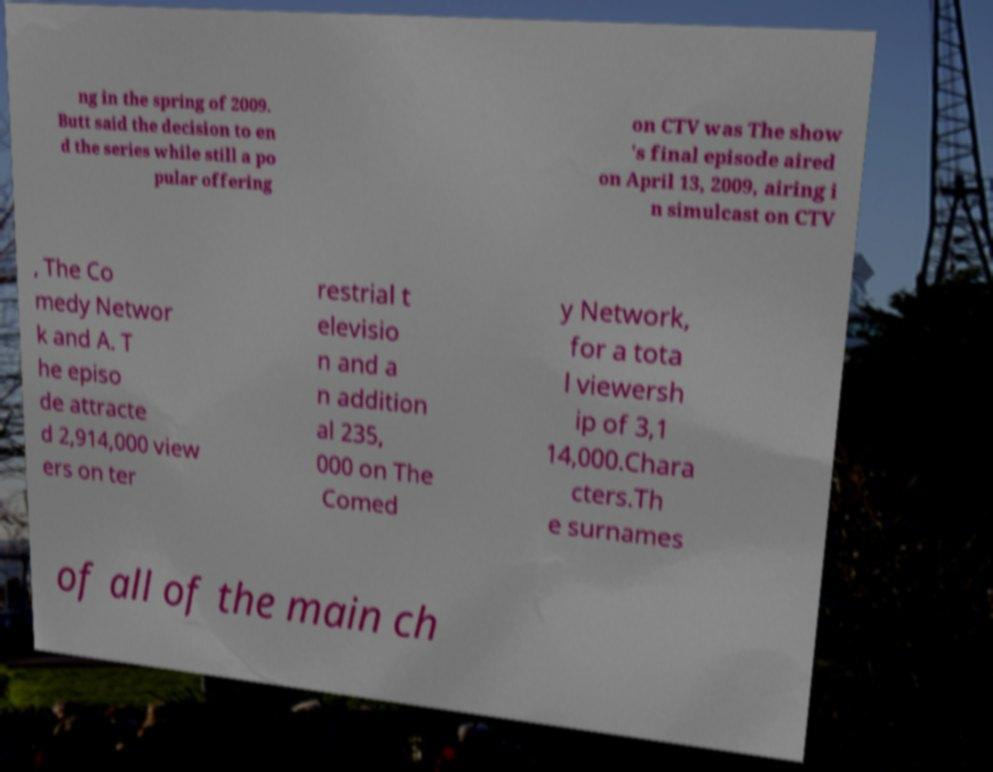Could you assist in decoding the text presented in this image and type it out clearly? ng in the spring of 2009. Butt said the decision to en d the series while still a po pular offering on CTV was The show 's final episode aired on April 13, 2009, airing i n simulcast on CTV , The Co medy Networ k and A. T he episo de attracte d 2,914,000 view ers on ter restrial t elevisio n and a n addition al 235, 000 on The Comed y Network, for a tota l viewersh ip of 3,1 14,000.Chara cters.Th e surnames of all of the main ch 